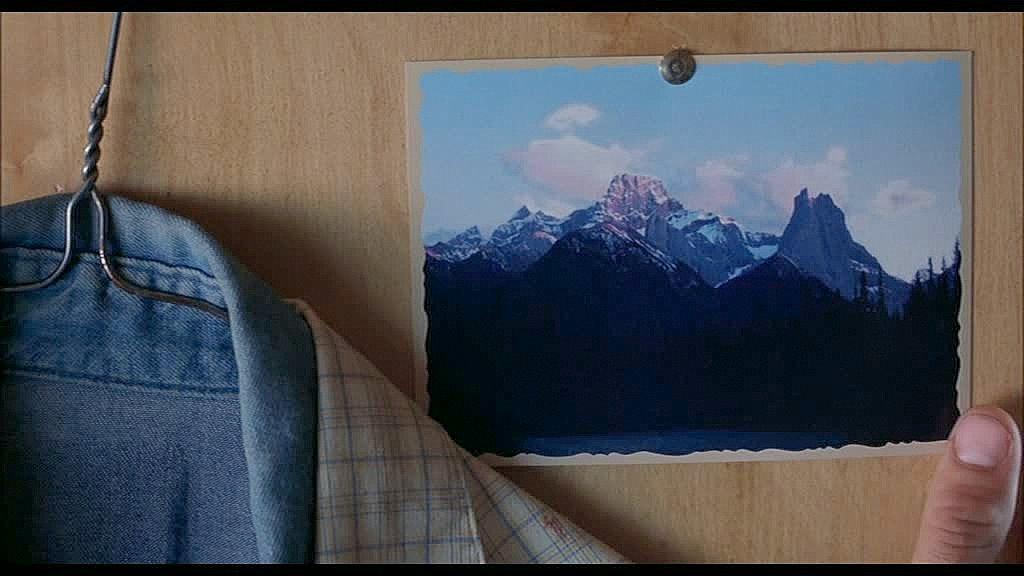What is the main subject of the image? There is a photograph on a wooden board in the image. Can you describe any human elements in the image? A person's finger is visible in the image. What else can be seen in the image besides the photograph and wooden board? Clothes are present in the image. What type of object is in the image? There is an object in the image. How many crates are stacked next to the person in the image? There are no crates present in the image. What type of toe is visible in the image? There is no toe visible in the image; only a person's finger can be seen. 